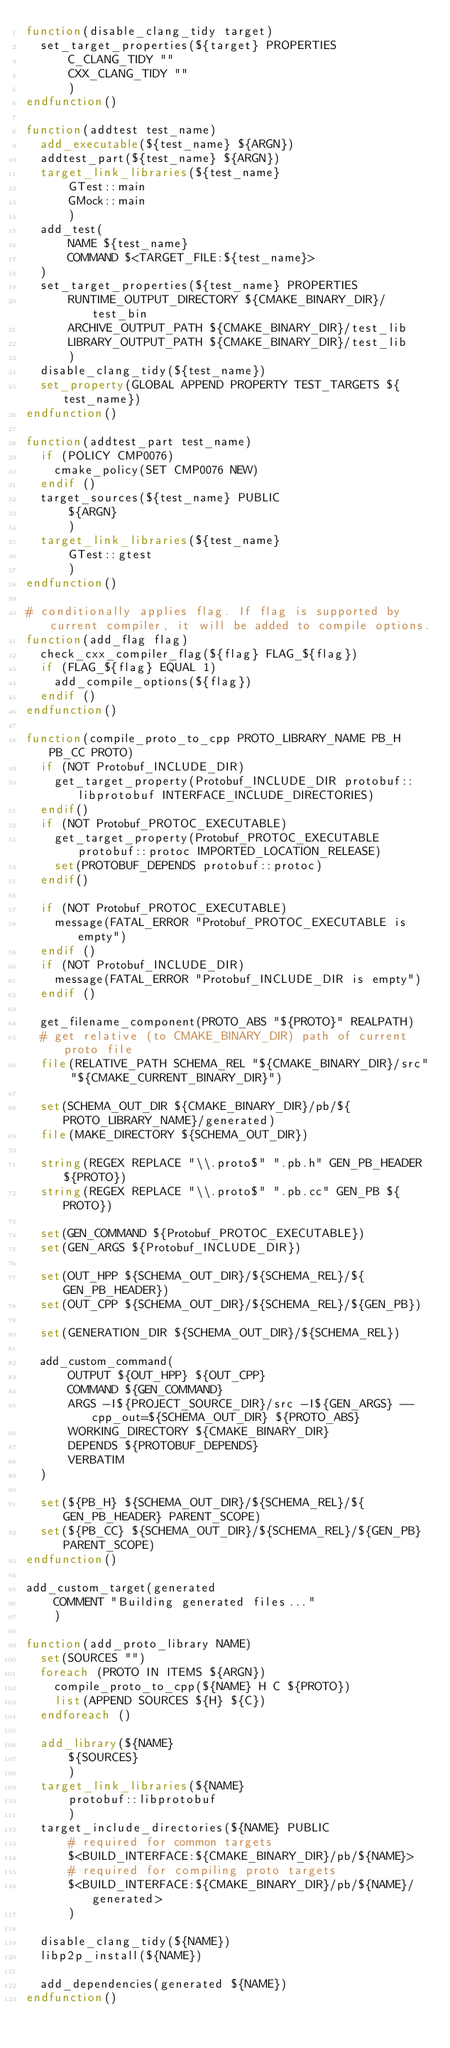<code> <loc_0><loc_0><loc_500><loc_500><_CMake_>function(disable_clang_tidy target)
  set_target_properties(${target} PROPERTIES
      C_CLANG_TIDY ""
      CXX_CLANG_TIDY ""
      )
endfunction()

function(addtest test_name)
  add_executable(${test_name} ${ARGN})
  addtest_part(${test_name} ${ARGN})
  target_link_libraries(${test_name}
      GTest::main
      GMock::main
      )
  add_test(
      NAME ${test_name}
      COMMAND $<TARGET_FILE:${test_name}>
  )
  set_target_properties(${test_name} PROPERTIES
      RUNTIME_OUTPUT_DIRECTORY ${CMAKE_BINARY_DIR}/test_bin
      ARCHIVE_OUTPUT_PATH ${CMAKE_BINARY_DIR}/test_lib
      LIBRARY_OUTPUT_PATH ${CMAKE_BINARY_DIR}/test_lib
      )
  disable_clang_tidy(${test_name})
  set_property(GLOBAL APPEND PROPERTY TEST_TARGETS ${test_name})
endfunction()

function(addtest_part test_name)
  if (POLICY CMP0076)
    cmake_policy(SET CMP0076 NEW)
  endif ()
  target_sources(${test_name} PUBLIC
      ${ARGN}
      )
  target_link_libraries(${test_name}
      GTest::gtest
      )
endfunction()

# conditionally applies flag. If flag is supported by current compiler, it will be added to compile options.
function(add_flag flag)
  check_cxx_compiler_flag(${flag} FLAG_${flag})
  if (FLAG_${flag} EQUAL 1)
    add_compile_options(${flag})
  endif ()
endfunction()

function(compile_proto_to_cpp PROTO_LIBRARY_NAME PB_H PB_CC PROTO)
  if (NOT Protobuf_INCLUDE_DIR)
    get_target_property(Protobuf_INCLUDE_DIR protobuf::libprotobuf INTERFACE_INCLUDE_DIRECTORIES)
  endif()
  if (NOT Protobuf_PROTOC_EXECUTABLE)
    get_target_property(Protobuf_PROTOC_EXECUTABLE protobuf::protoc IMPORTED_LOCATION_RELEASE)
    set(PROTOBUF_DEPENDS protobuf::protoc)
  endif()

  if (NOT Protobuf_PROTOC_EXECUTABLE)
    message(FATAL_ERROR "Protobuf_PROTOC_EXECUTABLE is empty")
  endif ()
  if (NOT Protobuf_INCLUDE_DIR)
    message(FATAL_ERROR "Protobuf_INCLUDE_DIR is empty")
  endif ()

  get_filename_component(PROTO_ABS "${PROTO}" REALPATH)
  # get relative (to CMAKE_BINARY_DIR) path of current proto file
  file(RELATIVE_PATH SCHEMA_REL "${CMAKE_BINARY_DIR}/src" "${CMAKE_CURRENT_BINARY_DIR}")

  set(SCHEMA_OUT_DIR ${CMAKE_BINARY_DIR}/pb/${PROTO_LIBRARY_NAME}/generated)
  file(MAKE_DIRECTORY ${SCHEMA_OUT_DIR})

  string(REGEX REPLACE "\\.proto$" ".pb.h" GEN_PB_HEADER ${PROTO})
  string(REGEX REPLACE "\\.proto$" ".pb.cc" GEN_PB ${PROTO})

  set(GEN_COMMAND ${Protobuf_PROTOC_EXECUTABLE})
  set(GEN_ARGS ${Protobuf_INCLUDE_DIR})

  set(OUT_HPP ${SCHEMA_OUT_DIR}/${SCHEMA_REL}/${GEN_PB_HEADER})
  set(OUT_CPP ${SCHEMA_OUT_DIR}/${SCHEMA_REL}/${GEN_PB})

  set(GENERATION_DIR ${SCHEMA_OUT_DIR}/${SCHEMA_REL})

  add_custom_command(
      OUTPUT ${OUT_HPP} ${OUT_CPP}
      COMMAND ${GEN_COMMAND}
      ARGS -I${PROJECT_SOURCE_DIR}/src -I${GEN_ARGS} --cpp_out=${SCHEMA_OUT_DIR} ${PROTO_ABS}
      WORKING_DIRECTORY ${CMAKE_BINARY_DIR}
      DEPENDS ${PROTOBUF_DEPENDS}
      VERBATIM
  )

  set(${PB_H} ${SCHEMA_OUT_DIR}/${SCHEMA_REL}/${GEN_PB_HEADER} PARENT_SCOPE)
  set(${PB_CC} ${SCHEMA_OUT_DIR}/${SCHEMA_REL}/${GEN_PB} PARENT_SCOPE)
endfunction()

add_custom_target(generated
    COMMENT "Building generated files..."
    )

function(add_proto_library NAME)
  set(SOURCES "")
  foreach (PROTO IN ITEMS ${ARGN})
    compile_proto_to_cpp(${NAME} H C ${PROTO})
    list(APPEND SOURCES ${H} ${C})
  endforeach ()

  add_library(${NAME}
      ${SOURCES}
      )
  target_link_libraries(${NAME}
      protobuf::libprotobuf
      )
  target_include_directories(${NAME} PUBLIC
      # required for common targets
      $<BUILD_INTERFACE:${CMAKE_BINARY_DIR}/pb/${NAME}>
      # required for compiling proto targets
      $<BUILD_INTERFACE:${CMAKE_BINARY_DIR}/pb/${NAME}/generated>
      )

  disable_clang_tidy(${NAME})
  libp2p_install(${NAME})

  add_dependencies(generated ${NAME})
endfunction()
</code> 